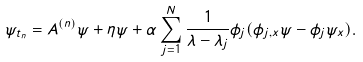Convert formula to latex. <formula><loc_0><loc_0><loc_500><loc_500>\psi _ { t _ { n } } = A ^ { ( n ) } \psi + \eta \psi + \alpha \sum _ { j = 1 } ^ { N } \frac { 1 } { \lambda - \lambda _ { j } } \phi _ { j } ( \phi _ { j , x } \psi - \phi _ { j } \psi _ { x } ) .</formula> 